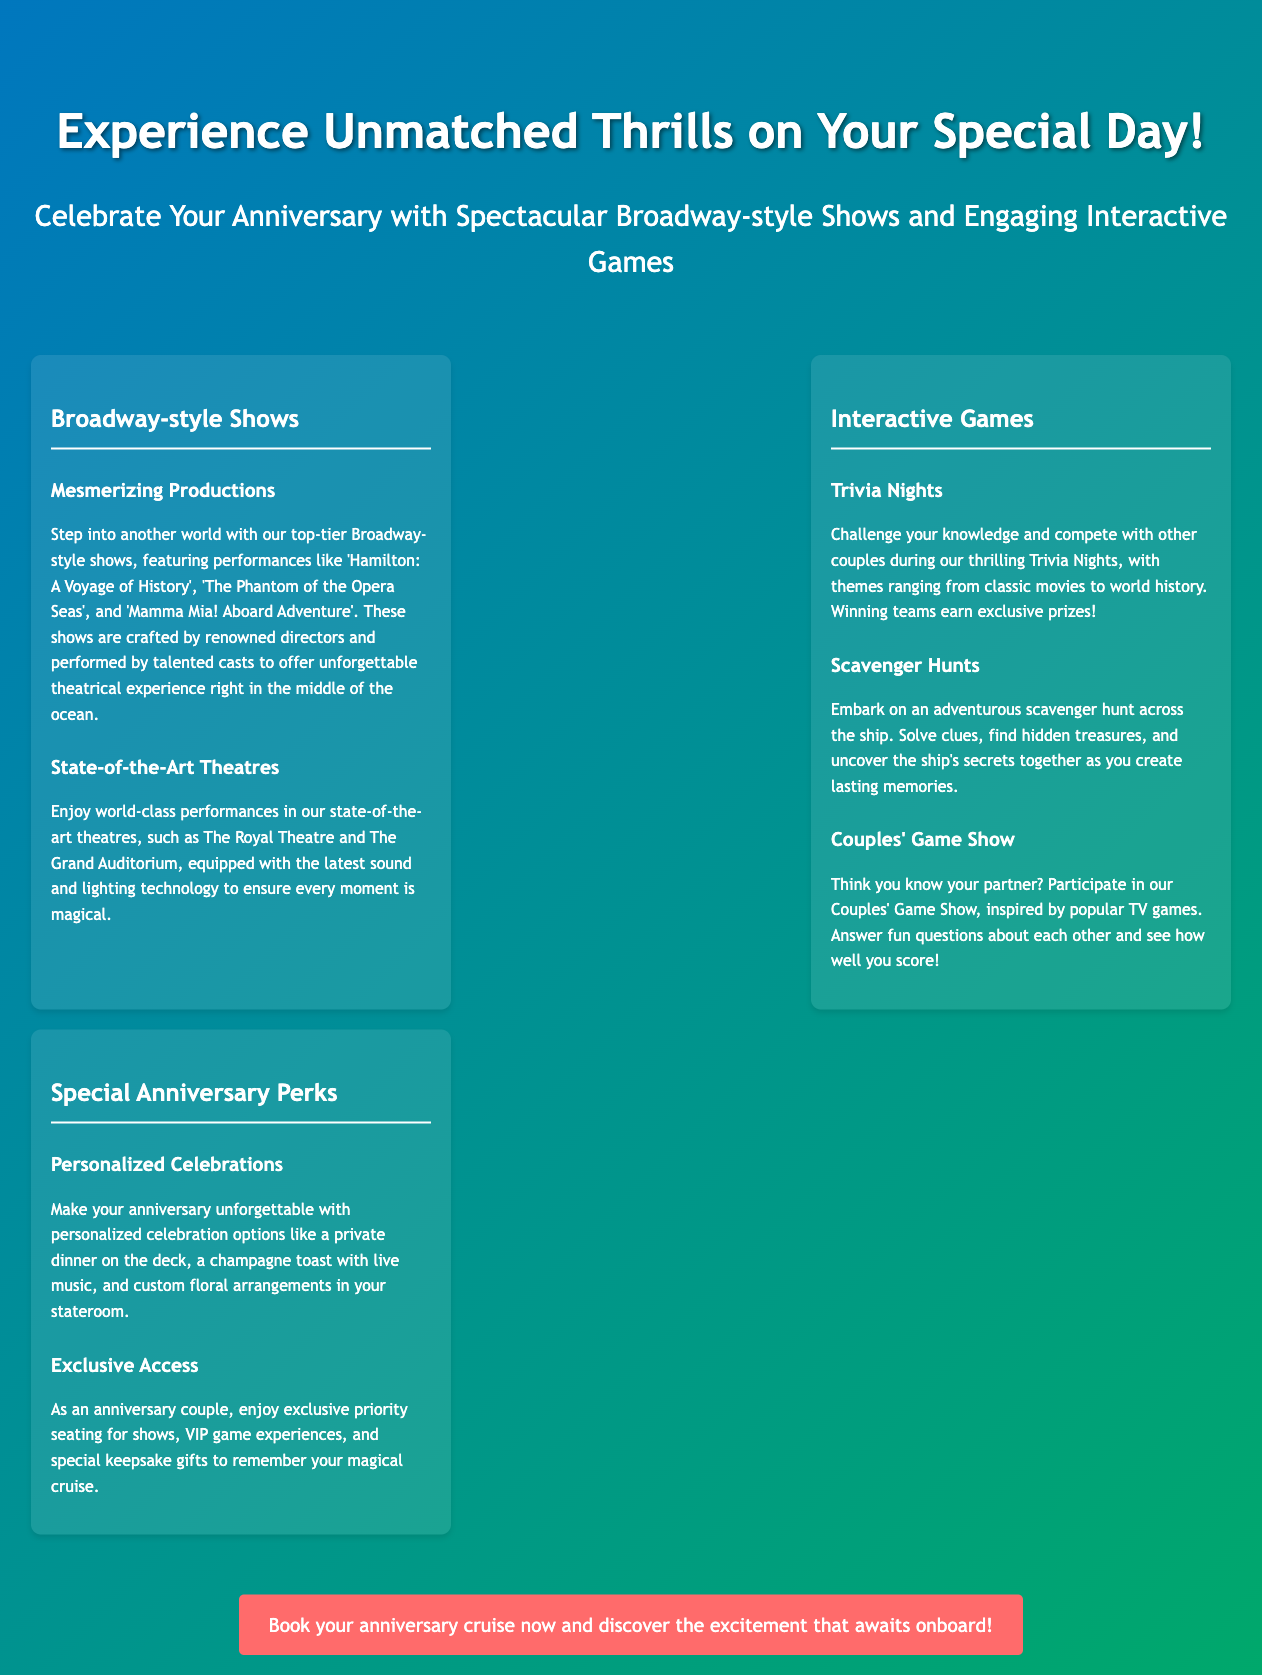What shows are featured? The document lists three shows: 'Hamilton: A Voyage of History', 'The Phantom of the Opera Seas', and 'Mamma Mia! Aboard Adventure'.
Answer: 'Hamilton: A Voyage of History', 'The Phantom of the Opera Seas', 'Mamma Mia! Aboard Adventure' What are Trivia Nights? Trivia Nights are events where couples can challenge their knowledge and compete on themes ranging from classic movies to world history.
Answer: Competitive knowledge events What kind of perks do anniversary couples receive? Anniversary couples can enjoy personalized celebration options, exclusive priority seating for shows, and special keepsake gifts.
Answer: Personalized celebrations, priority seating, keepsake gifts How many sections are there in the document? The document contains three sections focusing on Broadway-style shows, interactive games, and special anniversary perks.
Answer: Three sections What is the suggested action at the end of the document? The document encourages readers to book their anniversary cruise to discover the onboard excitement.
Answer: Book your anniversary cruise now 